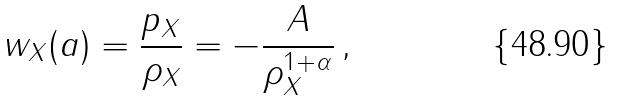<formula> <loc_0><loc_0><loc_500><loc_500>w _ { X } ( a ) = \frac { p _ { X } } { \rho _ { X } } = - \frac { A } { \rho _ { X } ^ { 1 + \alpha } } \, ,</formula> 